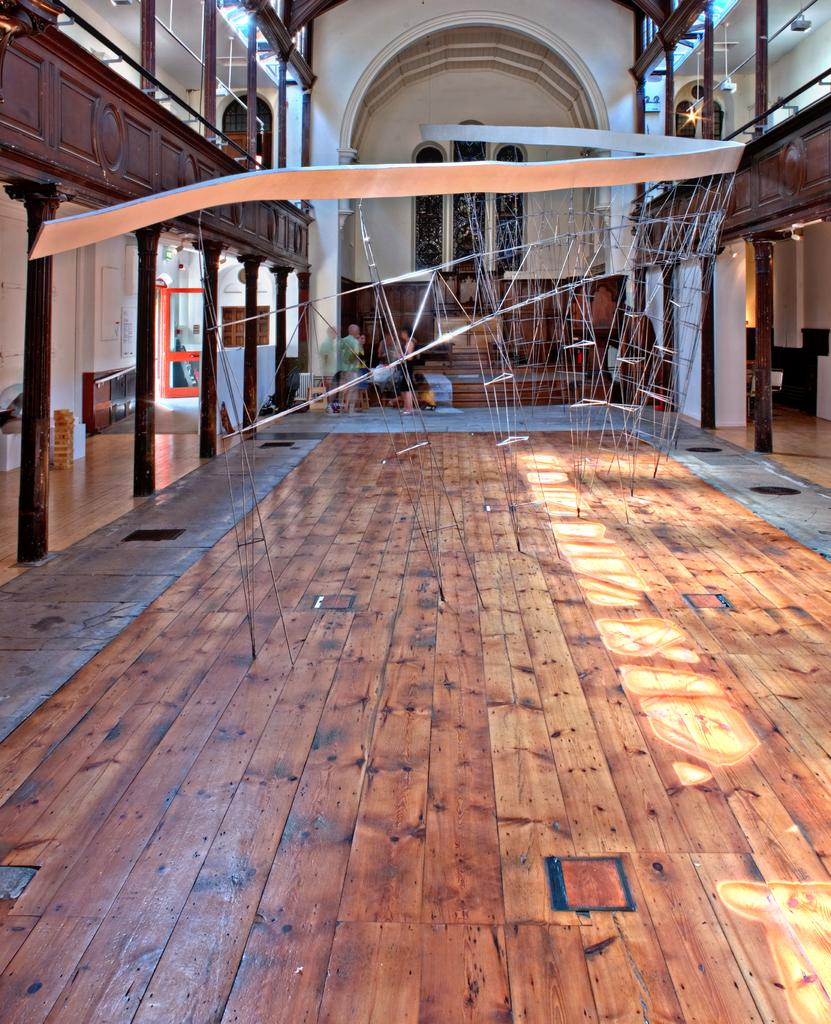What type of location is depicted in the image? The image shows an inner view of a building. What structural elements can be seen in the building? There are poles in the building. What type of lighting is present in the building? There are electric lights in the building. Are there any people present in the image? Yes, there are persons standing on the floor in the building. What type of feast is being prepared on the poles in the image? There is no feast or preparation of food visible in the image; the poles are structural elements within the building. How many bananas are hanging from the electric lights in the image? There are no bananas present in the image; the electric lights are for illumination purposes. 